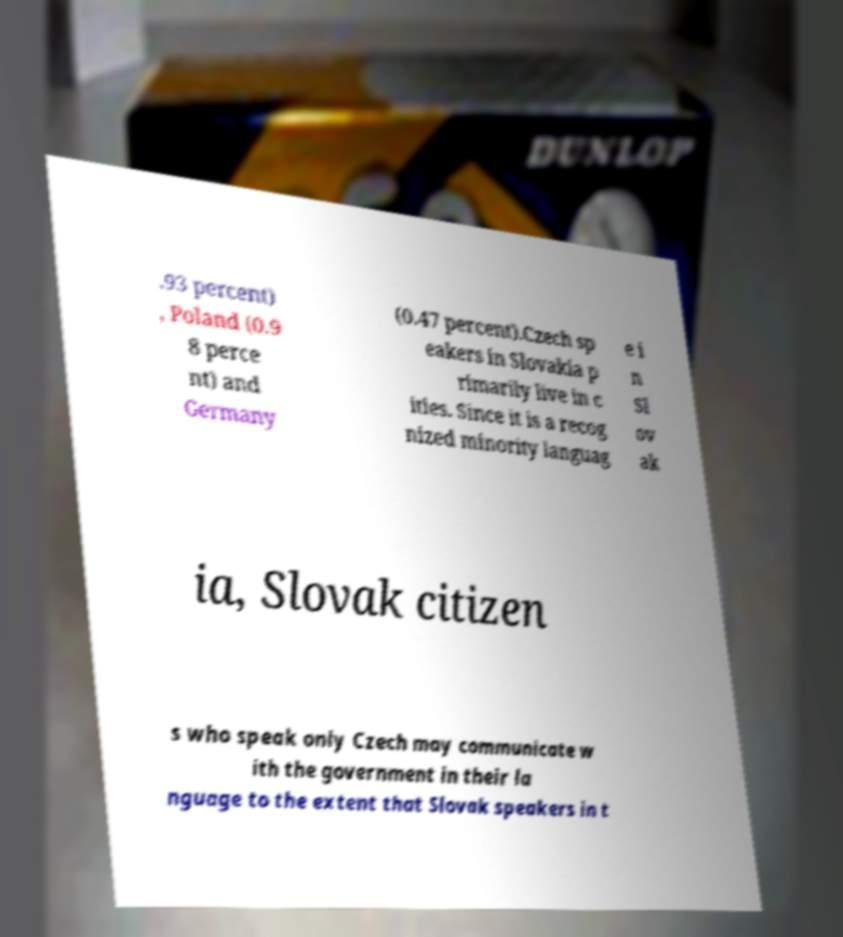There's text embedded in this image that I need extracted. Can you transcribe it verbatim? .93 percent) , Poland (0.9 8 perce nt) and Germany (0.47 percent).Czech sp eakers in Slovakia p rimarily live in c ities. Since it is a recog nized minority languag e i n Sl ov ak ia, Slovak citizen s who speak only Czech may communicate w ith the government in their la nguage to the extent that Slovak speakers in t 